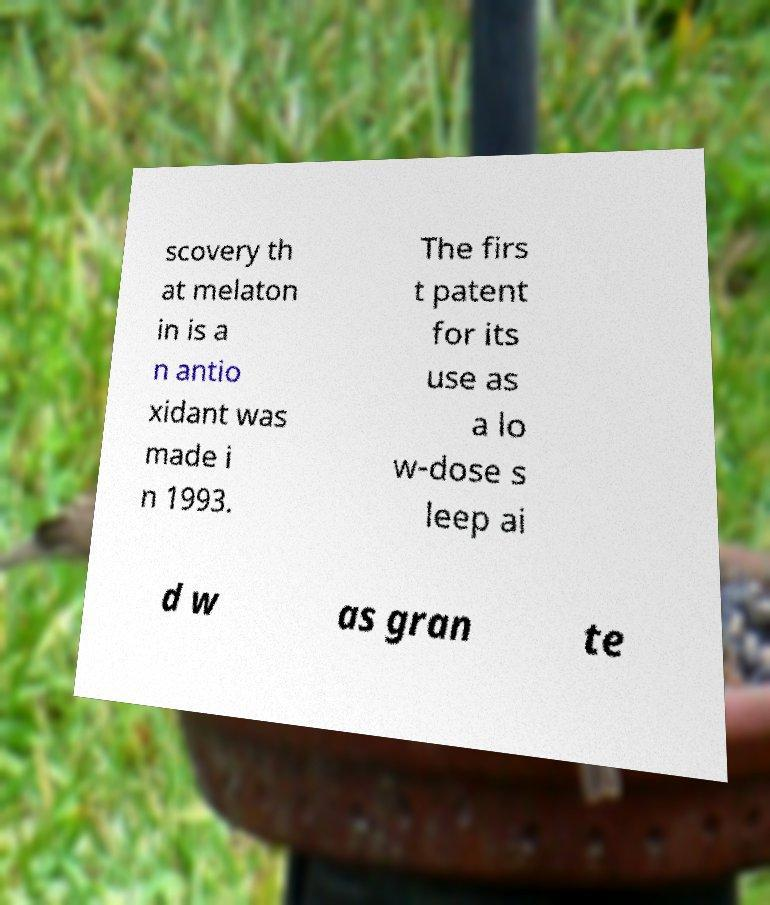For documentation purposes, I need the text within this image transcribed. Could you provide that? scovery th at melaton in is a n antio xidant was made i n 1993. The firs t patent for its use as a lo w-dose s leep ai d w as gran te 